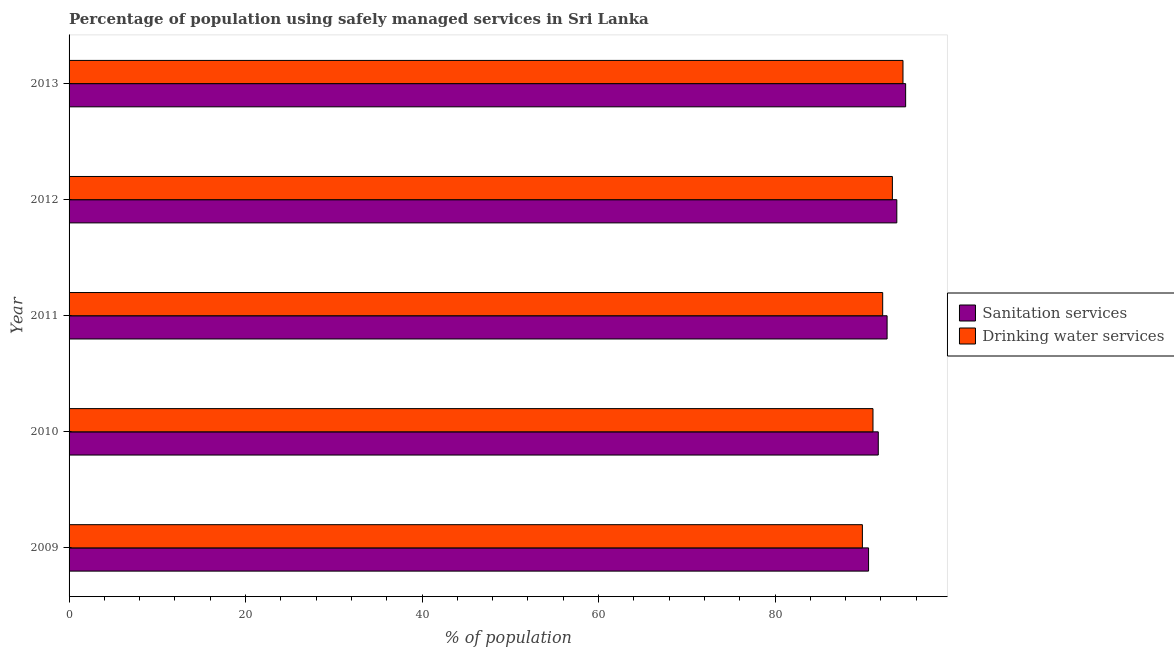How many different coloured bars are there?
Your answer should be very brief. 2. Are the number of bars on each tick of the Y-axis equal?
Your response must be concise. Yes. How many bars are there on the 2nd tick from the top?
Your answer should be very brief. 2. How many bars are there on the 4th tick from the bottom?
Offer a very short reply. 2. In how many cases, is the number of bars for a given year not equal to the number of legend labels?
Your answer should be very brief. 0. What is the percentage of population who used drinking water services in 2011?
Your answer should be very brief. 92.2. Across all years, what is the maximum percentage of population who used drinking water services?
Give a very brief answer. 94.5. Across all years, what is the minimum percentage of population who used sanitation services?
Ensure brevity in your answer.  90.6. What is the total percentage of population who used drinking water services in the graph?
Give a very brief answer. 461. What is the difference between the percentage of population who used drinking water services in 2010 and that in 2012?
Provide a succinct answer. -2.2. What is the difference between the percentage of population who used drinking water services in 2011 and the percentage of population who used sanitation services in 2012?
Offer a terse response. -1.6. What is the average percentage of population who used drinking water services per year?
Keep it short and to the point. 92.2. In the year 2011, what is the difference between the percentage of population who used sanitation services and percentage of population who used drinking water services?
Give a very brief answer. 0.5. Is the percentage of population who used drinking water services in 2011 less than that in 2012?
Your response must be concise. Yes. What is the difference between the highest and the second highest percentage of population who used drinking water services?
Make the answer very short. 1.2. In how many years, is the percentage of population who used sanitation services greater than the average percentage of population who used sanitation services taken over all years?
Offer a very short reply. 2. What does the 2nd bar from the top in 2010 represents?
Offer a very short reply. Sanitation services. What does the 1st bar from the bottom in 2009 represents?
Ensure brevity in your answer.  Sanitation services. How many bars are there?
Offer a very short reply. 10. Are all the bars in the graph horizontal?
Provide a succinct answer. Yes. What is the difference between two consecutive major ticks on the X-axis?
Your response must be concise. 20. Does the graph contain any zero values?
Provide a short and direct response. No. Where does the legend appear in the graph?
Your answer should be compact. Center right. How many legend labels are there?
Ensure brevity in your answer.  2. How are the legend labels stacked?
Offer a terse response. Vertical. What is the title of the graph?
Provide a succinct answer. Percentage of population using safely managed services in Sri Lanka. What is the label or title of the X-axis?
Your response must be concise. % of population. What is the label or title of the Y-axis?
Ensure brevity in your answer.  Year. What is the % of population in Sanitation services in 2009?
Your response must be concise. 90.6. What is the % of population of Drinking water services in 2009?
Provide a short and direct response. 89.9. What is the % of population in Sanitation services in 2010?
Provide a short and direct response. 91.7. What is the % of population in Drinking water services in 2010?
Give a very brief answer. 91.1. What is the % of population in Sanitation services in 2011?
Your answer should be compact. 92.7. What is the % of population in Drinking water services in 2011?
Keep it short and to the point. 92.2. What is the % of population of Sanitation services in 2012?
Keep it short and to the point. 93.8. What is the % of population of Drinking water services in 2012?
Provide a short and direct response. 93.3. What is the % of population of Sanitation services in 2013?
Give a very brief answer. 94.8. What is the % of population of Drinking water services in 2013?
Keep it short and to the point. 94.5. Across all years, what is the maximum % of population in Sanitation services?
Make the answer very short. 94.8. Across all years, what is the maximum % of population of Drinking water services?
Keep it short and to the point. 94.5. Across all years, what is the minimum % of population of Sanitation services?
Your response must be concise. 90.6. Across all years, what is the minimum % of population in Drinking water services?
Make the answer very short. 89.9. What is the total % of population of Sanitation services in the graph?
Your answer should be compact. 463.6. What is the total % of population in Drinking water services in the graph?
Provide a succinct answer. 461. What is the difference between the % of population of Drinking water services in 2009 and that in 2011?
Give a very brief answer. -2.3. What is the difference between the % of population in Drinking water services in 2009 and that in 2012?
Your answer should be very brief. -3.4. What is the difference between the % of population of Sanitation services in 2009 and that in 2013?
Offer a terse response. -4.2. What is the difference between the % of population of Drinking water services in 2009 and that in 2013?
Keep it short and to the point. -4.6. What is the difference between the % of population of Sanitation services in 2010 and that in 2011?
Offer a terse response. -1. What is the difference between the % of population of Drinking water services in 2010 and that in 2011?
Provide a succinct answer. -1.1. What is the difference between the % of population of Sanitation services in 2010 and that in 2012?
Your answer should be compact. -2.1. What is the difference between the % of population in Drinking water services in 2010 and that in 2012?
Your response must be concise. -2.2. What is the difference between the % of population in Sanitation services in 2010 and that in 2013?
Offer a very short reply. -3.1. What is the difference between the % of population in Drinking water services in 2010 and that in 2013?
Your response must be concise. -3.4. What is the difference between the % of population of Sanitation services in 2011 and that in 2012?
Your response must be concise. -1.1. What is the difference between the % of population in Sanitation services in 2012 and that in 2013?
Ensure brevity in your answer.  -1. What is the difference between the % of population in Sanitation services in 2009 and the % of population in Drinking water services in 2011?
Offer a very short reply. -1.6. What is the difference between the % of population of Sanitation services in 2009 and the % of population of Drinking water services in 2012?
Keep it short and to the point. -2.7. What is the difference between the % of population of Sanitation services in 2009 and the % of population of Drinking water services in 2013?
Offer a terse response. -3.9. What is the difference between the % of population of Sanitation services in 2011 and the % of population of Drinking water services in 2012?
Your response must be concise. -0.6. What is the difference between the % of population in Sanitation services in 2011 and the % of population in Drinking water services in 2013?
Provide a short and direct response. -1.8. What is the average % of population of Sanitation services per year?
Provide a succinct answer. 92.72. What is the average % of population of Drinking water services per year?
Offer a terse response. 92.2. In the year 2010, what is the difference between the % of population of Sanitation services and % of population of Drinking water services?
Offer a very short reply. 0.6. In the year 2012, what is the difference between the % of population in Sanitation services and % of population in Drinking water services?
Your answer should be very brief. 0.5. What is the ratio of the % of population in Drinking water services in 2009 to that in 2010?
Your answer should be compact. 0.99. What is the ratio of the % of population in Sanitation services in 2009 to that in 2011?
Provide a succinct answer. 0.98. What is the ratio of the % of population in Drinking water services in 2009 to that in 2011?
Make the answer very short. 0.98. What is the ratio of the % of population in Sanitation services in 2009 to that in 2012?
Offer a terse response. 0.97. What is the ratio of the % of population in Drinking water services in 2009 to that in 2012?
Offer a very short reply. 0.96. What is the ratio of the % of population of Sanitation services in 2009 to that in 2013?
Your answer should be very brief. 0.96. What is the ratio of the % of population in Drinking water services in 2009 to that in 2013?
Provide a short and direct response. 0.95. What is the ratio of the % of population of Sanitation services in 2010 to that in 2012?
Your answer should be very brief. 0.98. What is the ratio of the % of population in Drinking water services in 2010 to that in 2012?
Keep it short and to the point. 0.98. What is the ratio of the % of population in Sanitation services in 2010 to that in 2013?
Provide a short and direct response. 0.97. What is the ratio of the % of population of Sanitation services in 2011 to that in 2012?
Your answer should be very brief. 0.99. What is the ratio of the % of population of Drinking water services in 2011 to that in 2012?
Your response must be concise. 0.99. What is the ratio of the % of population of Sanitation services in 2011 to that in 2013?
Ensure brevity in your answer.  0.98. What is the ratio of the % of population of Drinking water services in 2011 to that in 2013?
Your response must be concise. 0.98. What is the ratio of the % of population of Sanitation services in 2012 to that in 2013?
Give a very brief answer. 0.99. What is the ratio of the % of population in Drinking water services in 2012 to that in 2013?
Your answer should be very brief. 0.99. What is the difference between the highest and the second highest % of population of Sanitation services?
Offer a terse response. 1. 